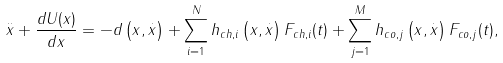<formula> <loc_0><loc_0><loc_500><loc_500>\overset { . . } { x } + \frac { d U ( x ) } { d x } = - d \left ( x , \overset { . } { x } \right ) + \sum _ { i = 1 } ^ { N } h _ { c h , i } \left ( x , \overset { . } { x } \right ) F _ { c h , i } ( t ) + \sum _ { j = 1 } ^ { M } h _ { c o , j } \left ( x , \overset { . } { x } \right ) F _ { c o , j } ( t ) ,</formula> 